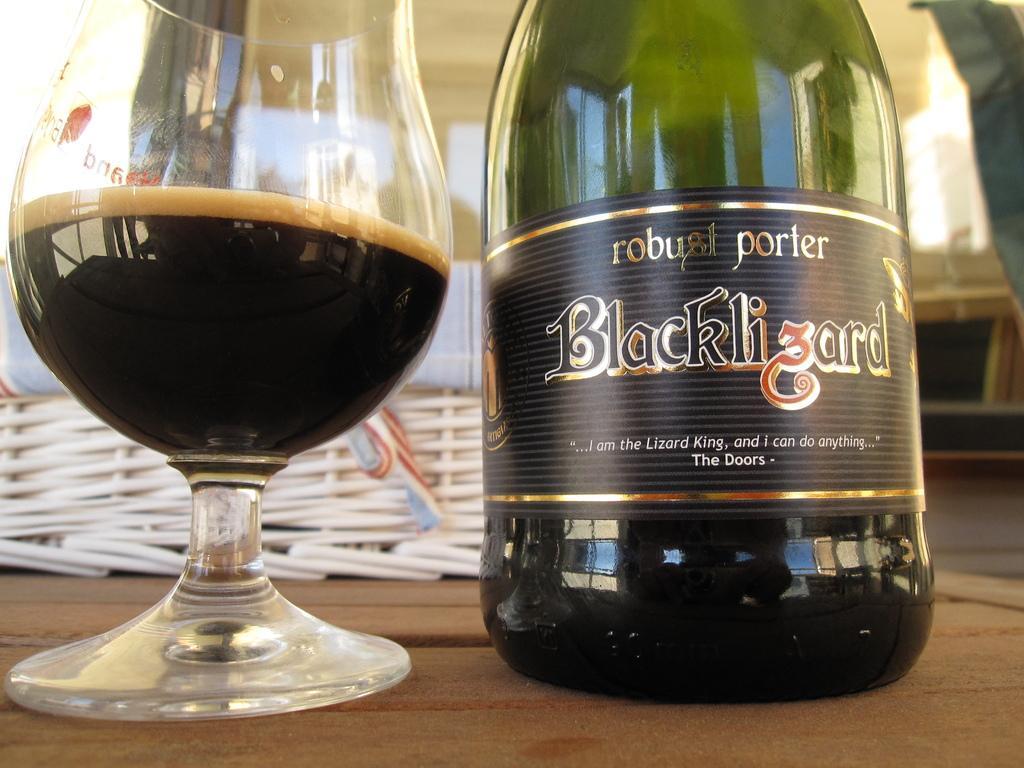Could you give a brief overview of what you see in this image? In this picture we can see a bottle and a glass with drink on the table. 